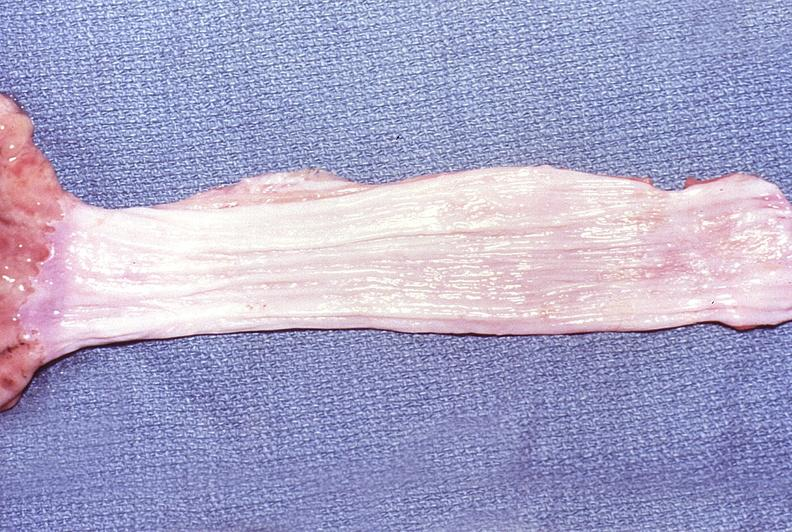what is present?
Answer the question using a single word or phrase. Gastrointestinal 